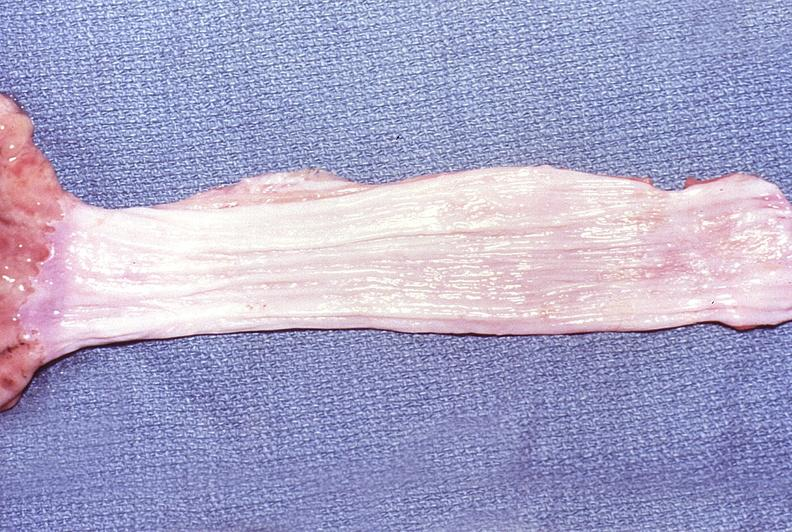what is present?
Answer the question using a single word or phrase. Gastrointestinal 